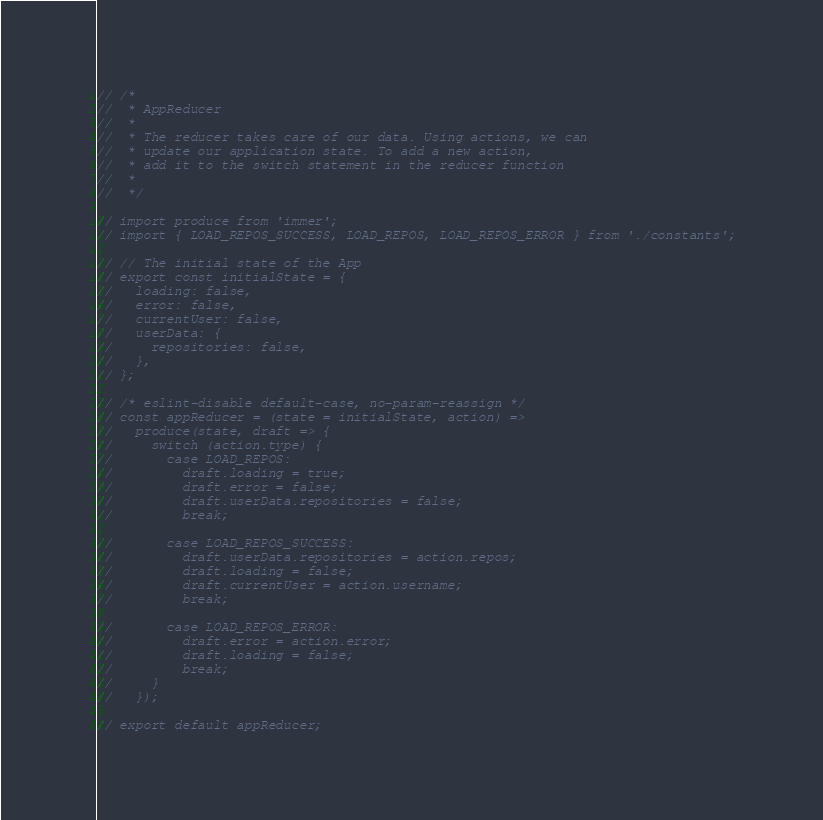<code> <loc_0><loc_0><loc_500><loc_500><_JavaScript_>// /*
//  * AppReducer
//  *
//  * The reducer takes care of our data. Using actions, we can
//  * update our application state. To add a new action,
//  * add it to the switch statement in the reducer function
//  *
//  */

// import produce from 'immer';
// import { LOAD_REPOS_SUCCESS, LOAD_REPOS, LOAD_REPOS_ERROR } from './constants';

// // The initial state of the App
// export const initialState = {
//   loading: false,
//   error: false,
//   currentUser: false,
//   userData: {
//     repositories: false,
//   },
// };

// /* eslint-disable default-case, no-param-reassign */
// const appReducer = (state = initialState, action) =>
//   produce(state, draft => {
//     switch (action.type) {
//       case LOAD_REPOS:
//         draft.loading = true;
//         draft.error = false;
//         draft.userData.repositories = false;
//         break;

//       case LOAD_REPOS_SUCCESS:
//         draft.userData.repositories = action.repos;
//         draft.loading = false;
//         draft.currentUser = action.username;
//         break;

//       case LOAD_REPOS_ERROR:
//         draft.error = action.error;
//         draft.loading = false;
//         break;
//     }
//   });

// export default appReducer;
</code> 